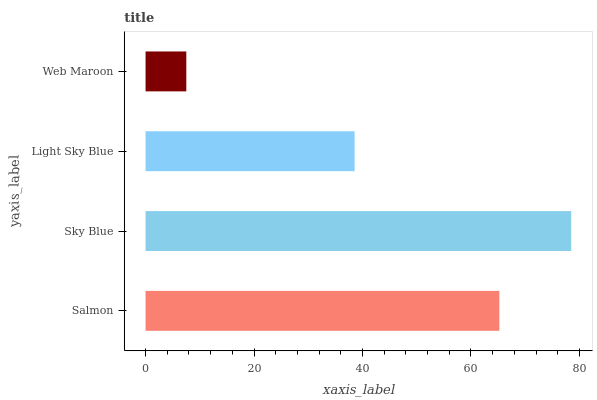Is Web Maroon the minimum?
Answer yes or no. Yes. Is Sky Blue the maximum?
Answer yes or no. Yes. Is Light Sky Blue the minimum?
Answer yes or no. No. Is Light Sky Blue the maximum?
Answer yes or no. No. Is Sky Blue greater than Light Sky Blue?
Answer yes or no. Yes. Is Light Sky Blue less than Sky Blue?
Answer yes or no. Yes. Is Light Sky Blue greater than Sky Blue?
Answer yes or no. No. Is Sky Blue less than Light Sky Blue?
Answer yes or no. No. Is Salmon the high median?
Answer yes or no. Yes. Is Light Sky Blue the low median?
Answer yes or no. Yes. Is Light Sky Blue the high median?
Answer yes or no. No. Is Salmon the low median?
Answer yes or no. No. 